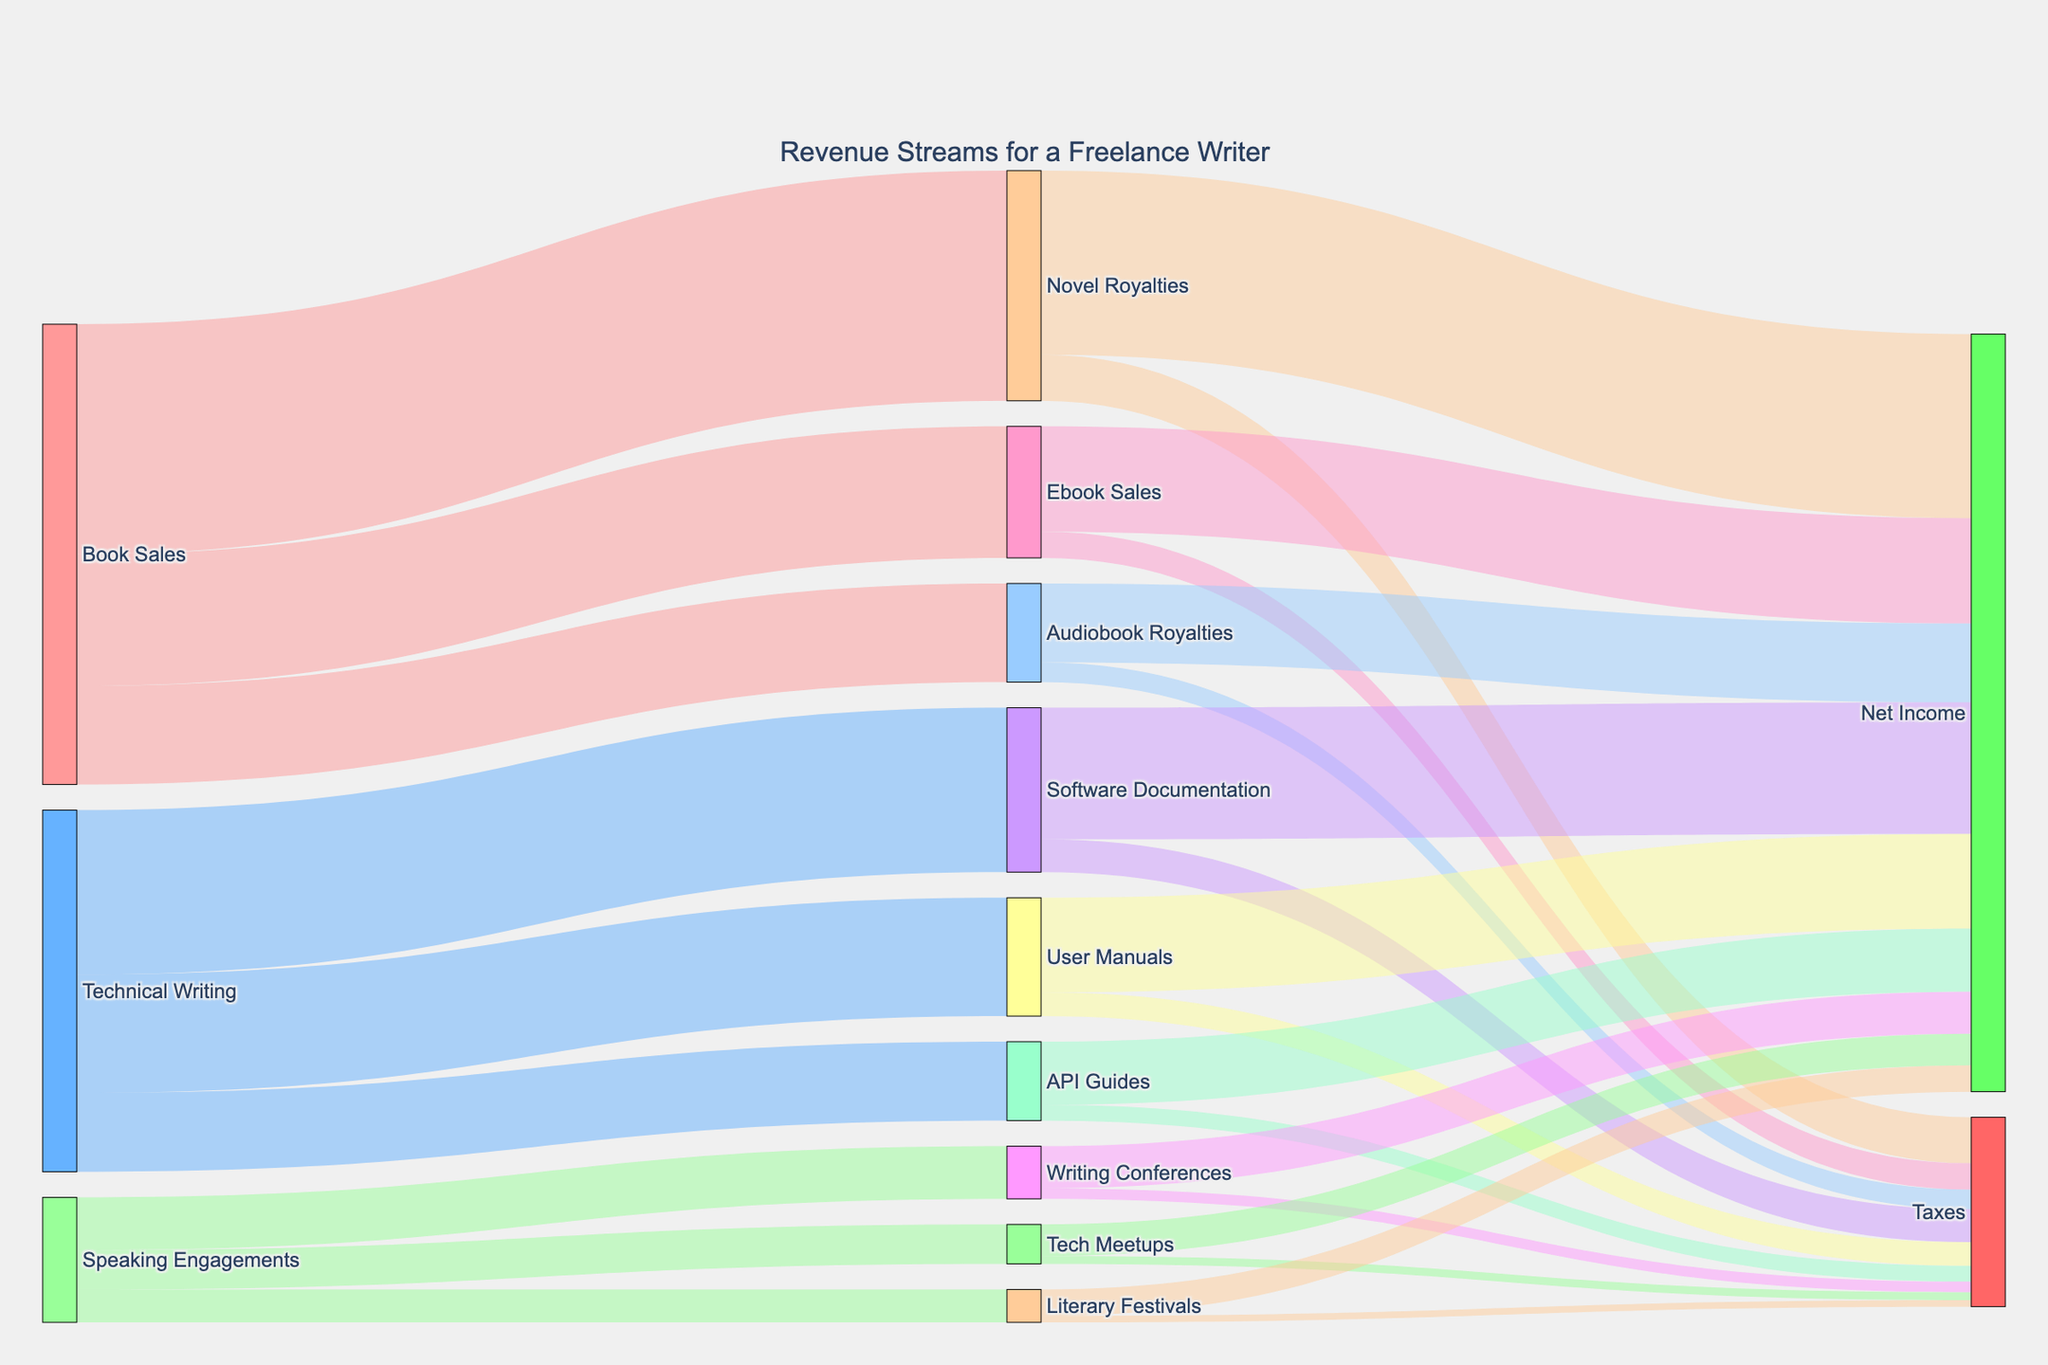What's the title of the figure? The title is displayed at the top center of the figure. It reads "Revenue Streams for a Freelance Writer".
Answer: Revenue Streams for a Freelance Writer How many types of revenue streams are shown for the freelance writer? The freelance writer has three main revenue streams: Book Sales, Technical Writing, and Speaking Engagements. These are identified by their distinct colors and labels in the figure.
Answer: 3 Which category contributes the most to the "Net Income"? To find the largest contribution to Net Income, look at the values flowing into the Net Income node. Summing the contributions from each primary income source, we see that Software Documentation from Technical Writing has the highest individual value of $20,000 under its Net Income category.
Answer: Software Documentation What is the total value of revenue from Book Sales? To find the total value of revenue from Book Sales, sum all the values flowing from the Book Sales node. Add $35,000 for Novel Royalties, $20,000 for Ebook Sales, and $15,000 for Audiobook Royalties. The total is $35,000 + $20,000 + $15,000 = $70,000
Answer: $70,000 Which revenue stream has the smallest contribution to Net Income? To find the smallest contribution to Net Income, look at the values flowing into the Net Income node and identify the smallest value. Literary Festivals under Speaking Engagements contributes $4,000, which is the smallest amount.
Answer: Literary Festivals How much of the revenue from Technical Writing is paid in taxes? Sum the tax amounts for Software Documentation ($5,000), User Manuals ($3,600), and API Guides ($2,400) under Technical Writing. The total taxes are $5,000 + $3,600 + $2,400 = $11,000.
Answer: $11,000 Which revenue stream pays the highest percentage in taxes? Calculate the percentage of taxes for each revenue stream. For instance, Novel Royalties pay $7,000 in taxes out of $35,000, resulting in $7,000 / $35,000 = 20%. Compare each percentage to find the highest. In this case, Writing Conferences pay $1,600 out of $8,000, which is 20%, and others result in lower percentages. Hence, Novel Royalties and Writing Conferences both pay the highest percentage in taxes with 20%.
Answer: Novel Royalties and Writing Conferences What is the combined Net Income from Speaking Engagements? Sum the Net Income values from Writing Conferences ($6,400), Tech Meetups ($4,800), and Literary Festivals ($4,000). The combined Net Income is $6,400 + $4,800 + $4,000 = $15,200.
Answer: $15,200 